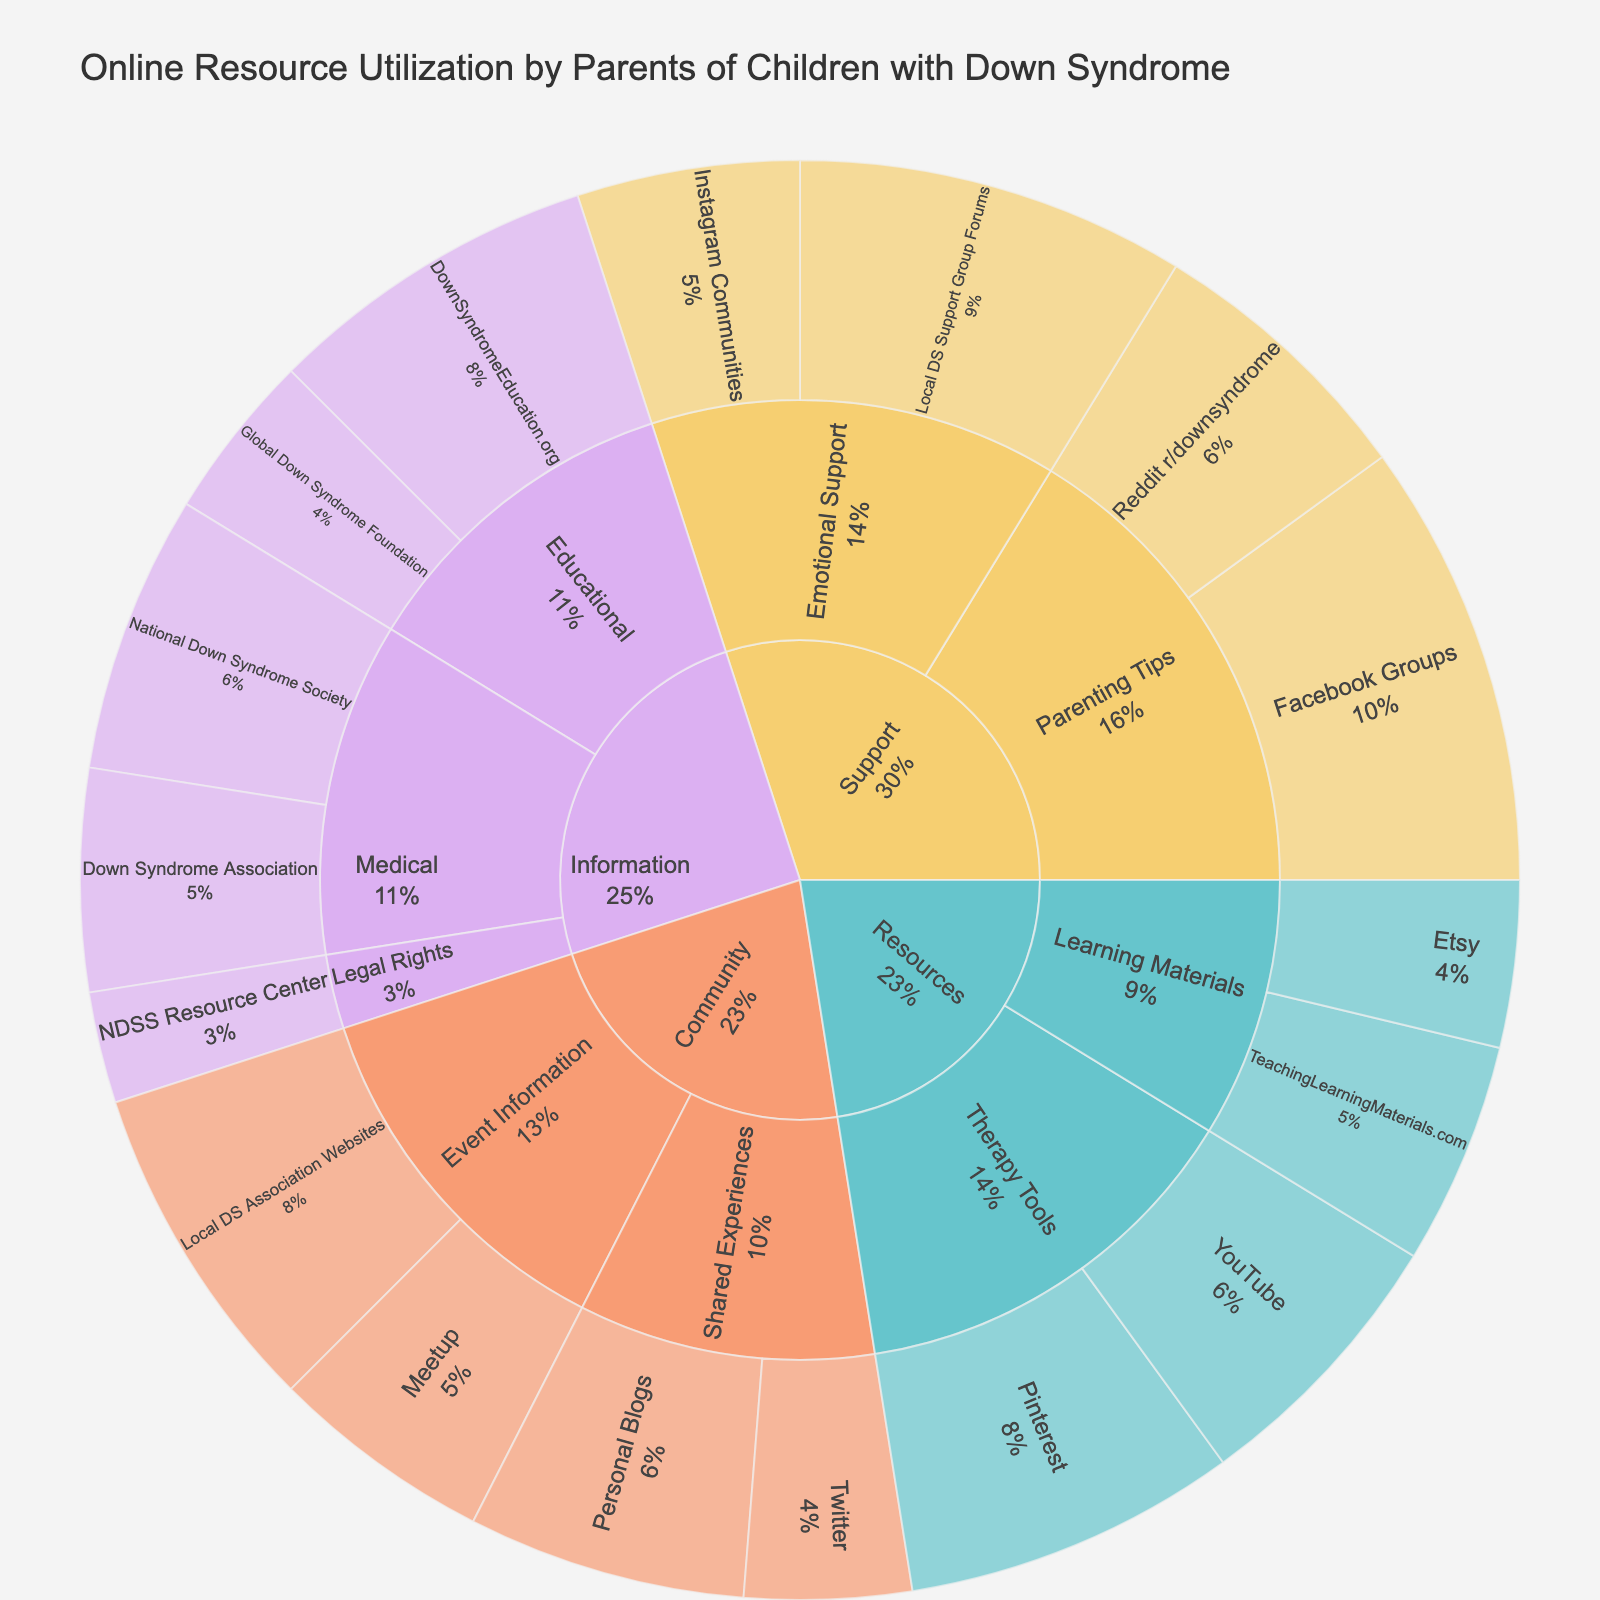What is the most utilized online resource platform for parenting tips? Look for the "Support" category and then the "Parenting Tips" subcategory. The "Facebook Groups" platform shows the highest usage in this subcategory.
Answer: Facebook Groups How much usage is observed in the "Medical" subcategory of the "Information" category? Add the usage values of all platforms under the "Medical" subcategory of the "Information" category. 25 (National Down Syndrome Society) + 20 (Down Syndrome Association) = 45.
Answer: 45 Which subcategory under the "Community" category receives higher usage, "Event Information" or "Shared Experiences"? Compare the usage values for "Event Information" (Local DS Association Websites: 30, Meetup: 20) and "Shared Experiences" (Personal Blogs: 25, Twitter: 15). "Event Information" has a total of 50, while "Shared Experiences" has a total of 40.
Answer: Event Information What percentage of the total usage is dedicated to "Therapy Tools" under the "Resources" category? First, find the total usage for "Therapy Tools" (Pinterest: 30, YouTube: 25) which equals 55. Then, sum the total usage across all categories (25+20+30+15+10+40+25+35+20+30+25+20+15+30+20+25+15=395). The percentage is (55/395) * 100 = 13.9%.
Answer: 13.9% Which platform in the "Educational" subcategory of the "Information" category has a higher usage, DownSyndromeEducation.org or Global Down Syndrome Foundation? Compare the usage of DownSyndromeEducation.org (30) with Global Down Syndrome Foundation (15). DownSyndromeEducation.org has higher usage.
Answer: DownSyndromeEducation.org How does the usage for "Local DS Support Group Forums" compare to "Instagram Communities" under the "Emotional Support" subcategory? For "Emotional Support", compare "Local DS Support Group Forums" (35) with "Instagram Communities" (20). "Local DS Support Group Forums" has higher usage.
Answer: Local DS Support Group Forums What is the total usage of all platforms in the "Resources" category? Add the usage values for all platforms under the "Resources" category: Pinterest (30) + YouTube (25) + TeachingLearningMaterials.com (20) + Etsy (15) = 90.
Answer: 90 In the "Information" category, which subcategory has the lowest total usage? Compare the total usage of each subcategory in the "Information" category. "Medical" has 45, "Educational" has 45, and "Legal Rights" has 10. The "Legal Rights" subcategory has the lowest total usage.
Answer: Legal Rights What is the usage differential between the most and least used platforms in the "Support" category? In the "Support" category, the most used platform is Facebook Groups (40) and the least used is Instagram Communities (20). The differential is 40 - 20 = 20.
Answer: 20 